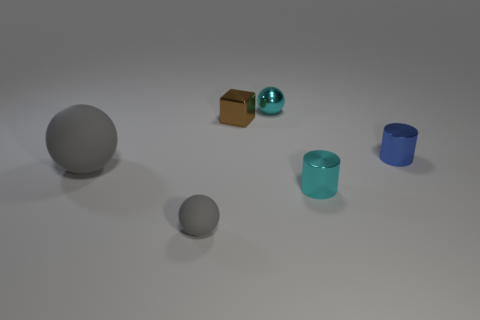The thing that is both on the right side of the small cyan shiny ball and in front of the blue cylinder is what color? The object fitting that description appears to be a smaller brown cube. Its earthy brown hue stands out against the more vibrant blues of the nearby shapes, reflecting an understated simplicity amidst the collection of objects. 